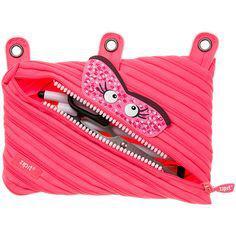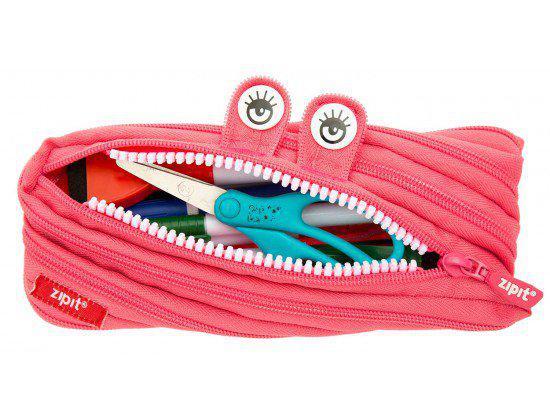The first image is the image on the left, the second image is the image on the right. Analyze the images presented: Is the assertion "One pouch is pink and the other pouch is red." valid? Answer yes or no. No. The first image is the image on the left, the second image is the image on the right. For the images shown, is this caption "At least one of the pouches has holes along the top to fit it into a three-ring binder." true? Answer yes or no. Yes. 